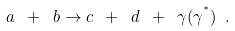<formula> <loc_0><loc_0><loc_500><loc_500>a \ + \ b \rightarrow c \ + \ d \ + \ \gamma ( \gamma ^ { ^ { * } } ) \ .</formula> 